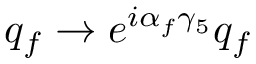Convert formula to latex. <formula><loc_0><loc_0><loc_500><loc_500>q _ { f } \rightarrow e ^ { i \alpha _ { f } \gamma _ { 5 } } q _ { f }</formula> 